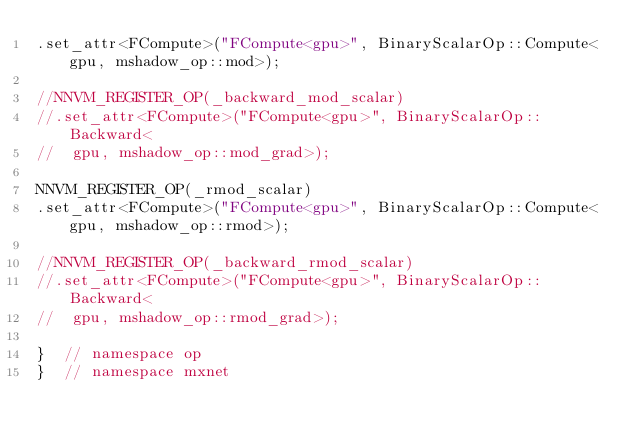<code> <loc_0><loc_0><loc_500><loc_500><_Cuda_>.set_attr<FCompute>("FCompute<gpu>", BinaryScalarOp::Compute<gpu, mshadow_op::mod>);

//NNVM_REGISTER_OP(_backward_mod_scalar)
//.set_attr<FCompute>("FCompute<gpu>", BinaryScalarOp::Backward<
//  gpu, mshadow_op::mod_grad>);

NNVM_REGISTER_OP(_rmod_scalar)
.set_attr<FCompute>("FCompute<gpu>", BinaryScalarOp::Compute<gpu, mshadow_op::rmod>);

//NNVM_REGISTER_OP(_backward_rmod_scalar)
//.set_attr<FCompute>("FCompute<gpu>", BinaryScalarOp::Backward<
//  gpu, mshadow_op::rmod_grad>);

}  // namespace op
}  // namespace mxnet
</code> 